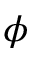Convert formula to latex. <formula><loc_0><loc_0><loc_500><loc_500>\phi</formula> 